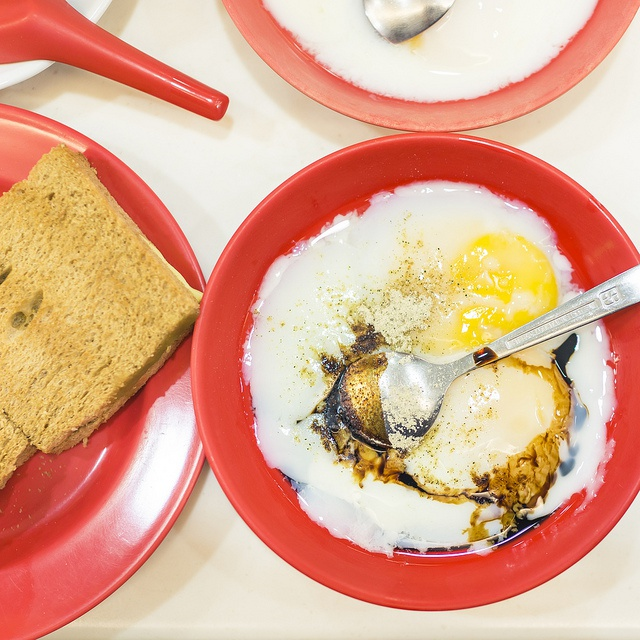Describe the objects in this image and their specific colors. I can see bowl in red, ivory, and khaki tones, dining table in red, ivory, tan, and salmon tones, sandwich in red, tan, khaki, and olive tones, and spoon in red, lightgray, beige, darkgray, and gray tones in this image. 